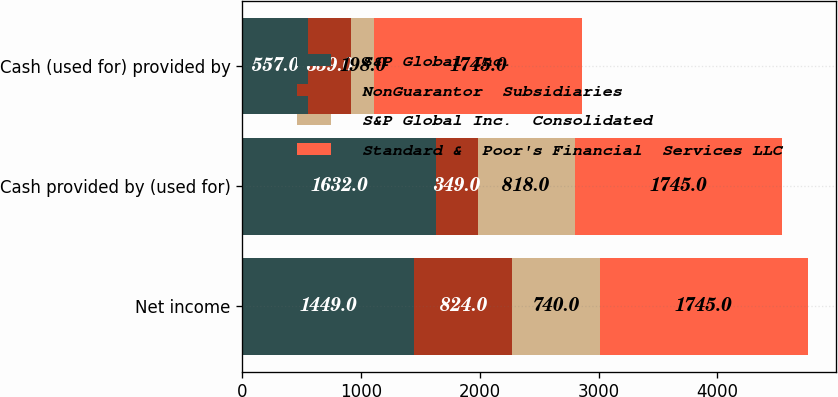<chart> <loc_0><loc_0><loc_500><loc_500><stacked_bar_chart><ecel><fcel>Net income<fcel>Cash provided by (used for)<fcel>Cash (used for) provided by<nl><fcel>S&P Global Inc.<fcel>1449<fcel>1632<fcel>557<nl><fcel>NonGuarantor  Subsidiaries<fcel>824<fcel>349<fcel>359<nl><fcel>S&P Global Inc.  Consolidated<fcel>740<fcel>818<fcel>198<nl><fcel>Standard &  Poor's Financial  Services LLC<fcel>1745<fcel>1745<fcel>1745<nl></chart> 